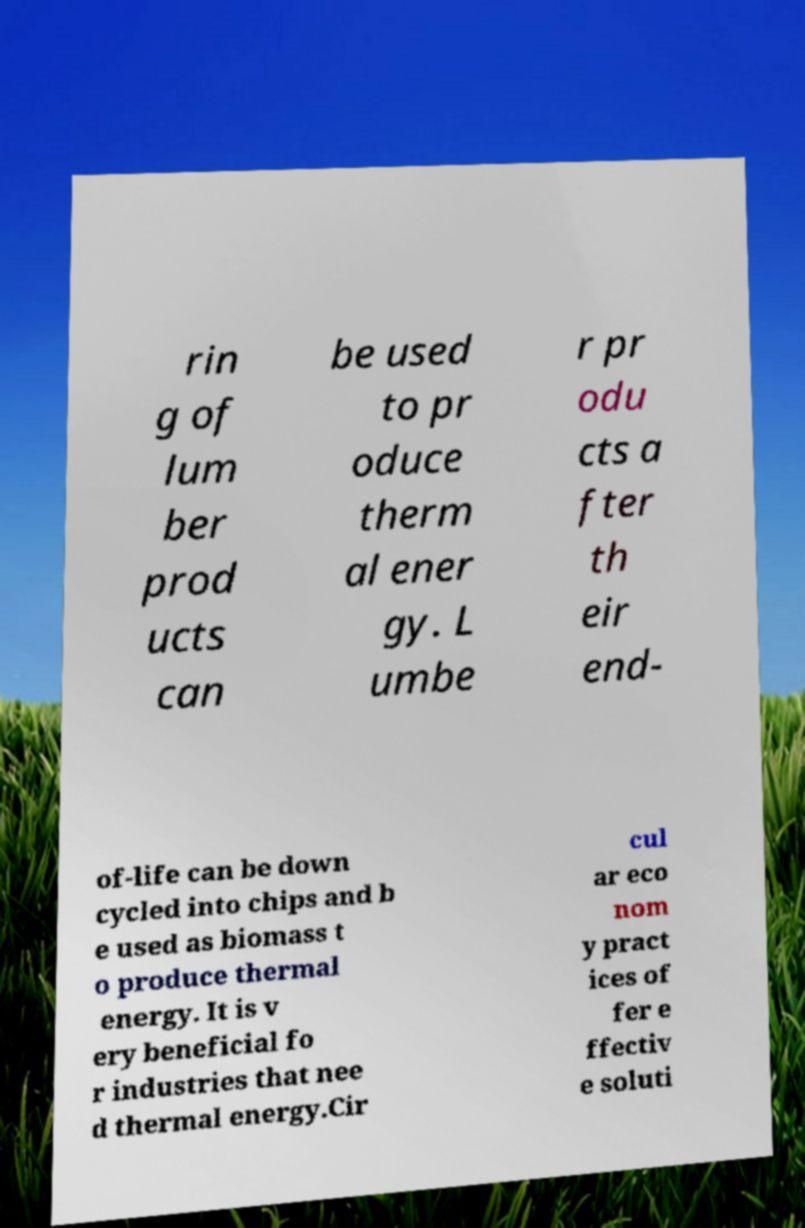Could you assist in decoding the text presented in this image and type it out clearly? rin g of lum ber prod ucts can be used to pr oduce therm al ener gy. L umbe r pr odu cts a fter th eir end- of-life can be down cycled into chips and b e used as biomass t o produce thermal energy. It is v ery beneficial fo r industries that nee d thermal energy.Cir cul ar eco nom y pract ices of fer e ffectiv e soluti 